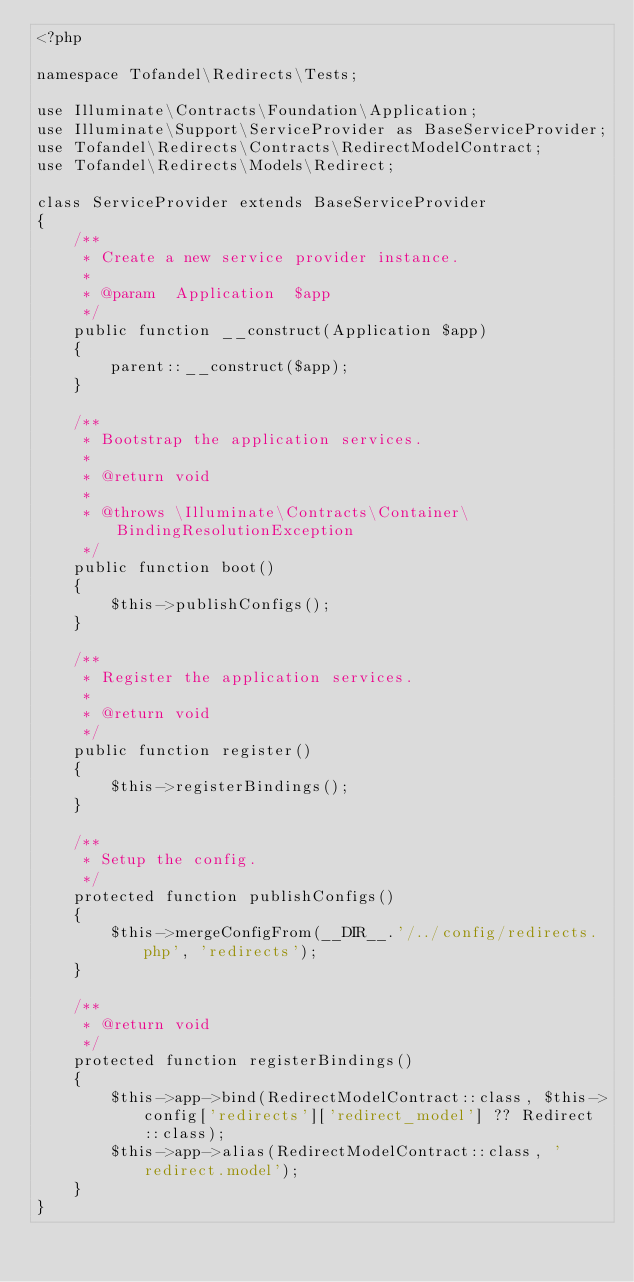Convert code to text. <code><loc_0><loc_0><loc_500><loc_500><_PHP_><?php

namespace Tofandel\Redirects\Tests;

use Illuminate\Contracts\Foundation\Application;
use Illuminate\Support\ServiceProvider as BaseServiceProvider;
use Tofandel\Redirects\Contracts\RedirectModelContract;
use Tofandel\Redirects\Models\Redirect;

class ServiceProvider extends BaseServiceProvider
{
    /**
     * Create a new service provider instance.
     *
     * @param  Application  $app
     */
    public function __construct(Application $app)
    {
        parent::__construct($app);
    }

    /**
     * Bootstrap the application services.
     *
     * @return void
     *
     * @throws \Illuminate\Contracts\Container\BindingResolutionException
     */
    public function boot()
    {
        $this->publishConfigs();
    }

    /**
     * Register the application services.
     *
     * @return void
     */
    public function register()
    {
        $this->registerBindings();
    }

    /**
     * Setup the config.
     */
    protected function publishConfigs()
    {
        $this->mergeConfigFrom(__DIR__.'/../config/redirects.php', 'redirects');
    }

    /**
     * @return void
     */
    protected function registerBindings()
    {
        $this->app->bind(RedirectModelContract::class, $this->config['redirects']['redirect_model'] ?? Redirect::class);
        $this->app->alias(RedirectModelContract::class, 'redirect.model');
    }
}
</code> 